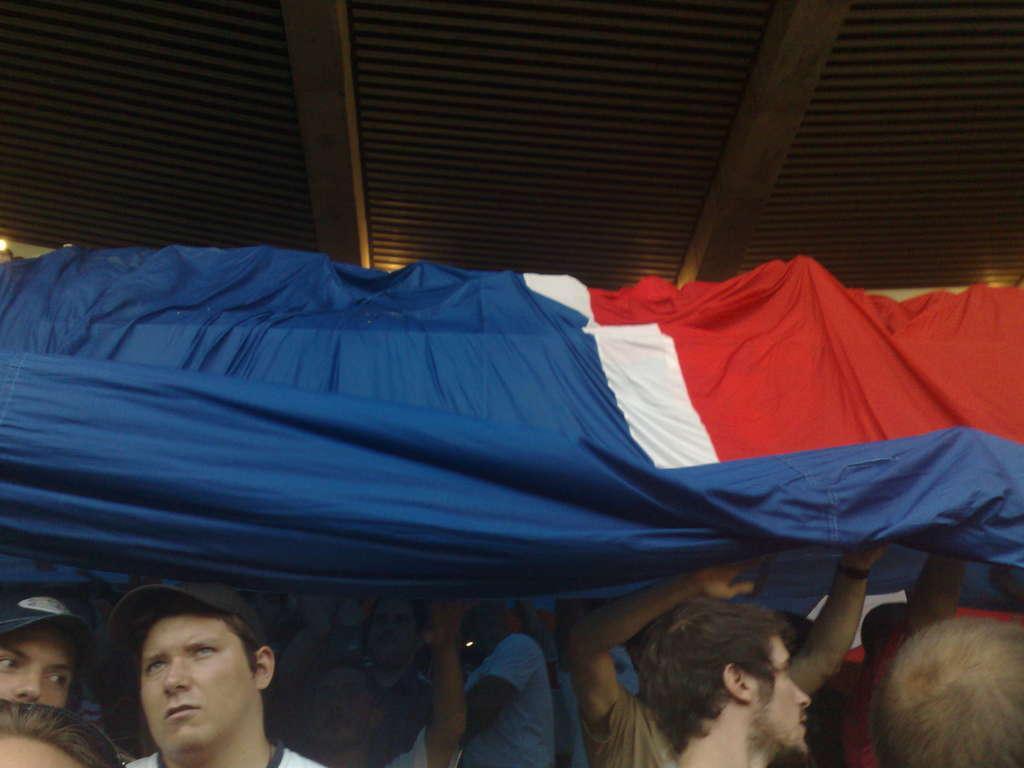Can you describe this image briefly? In the foreground of this image, there are people holding flag. At the top, there is ceiling. 